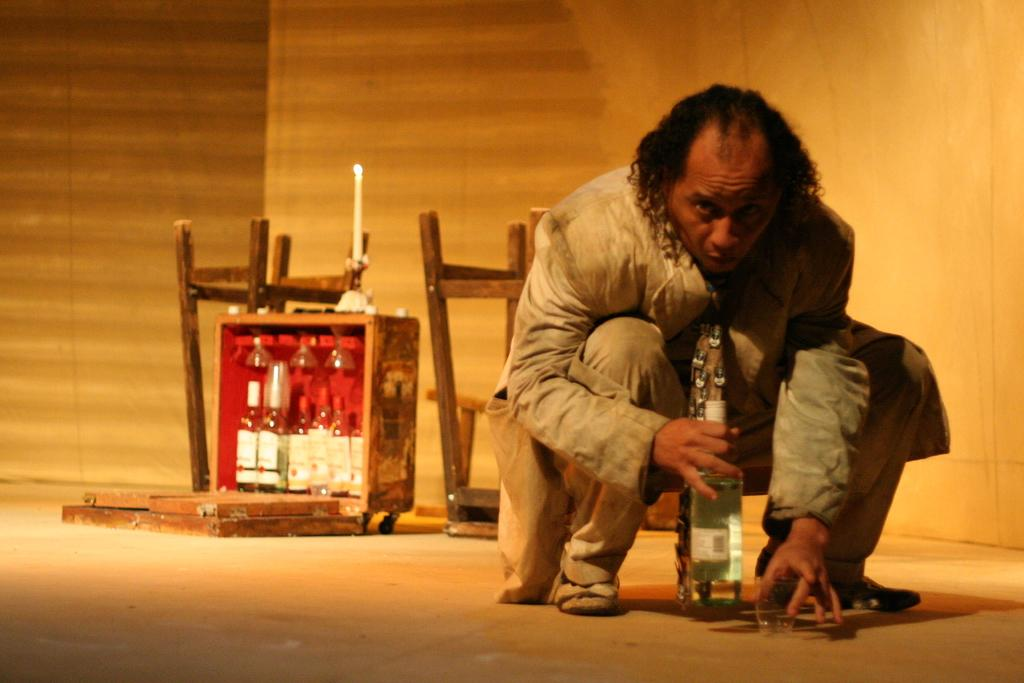What is the main subject in the foreground of the picture? There is a person in the foreground of the picture. What is the person holding in the picture? The person is holding a bottle and a glass. Are there any other bottles visible in the picture? Yes, there are bottles beside the person. What else can be seen near the person? There are chairs beside the person. What can be seen in the background of the picture? There is a wooden wall in the background of the picture. What type of business is the maid conducting in the picture? There is no maid present in the picture, and no business is being conducted. 